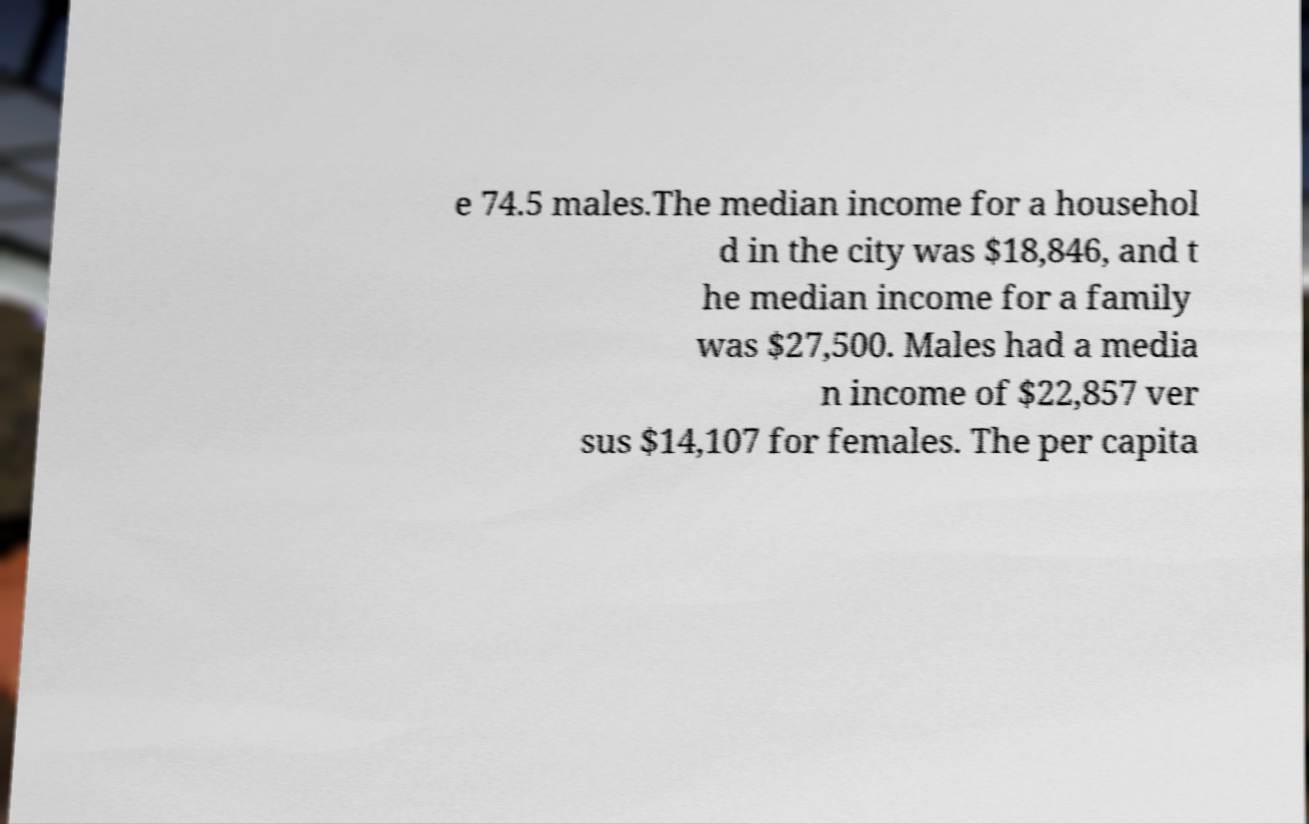Please identify and transcribe the text found in this image. e 74.5 males.The median income for a househol d in the city was $18,846, and t he median income for a family was $27,500. Males had a media n income of $22,857 ver sus $14,107 for females. The per capita 